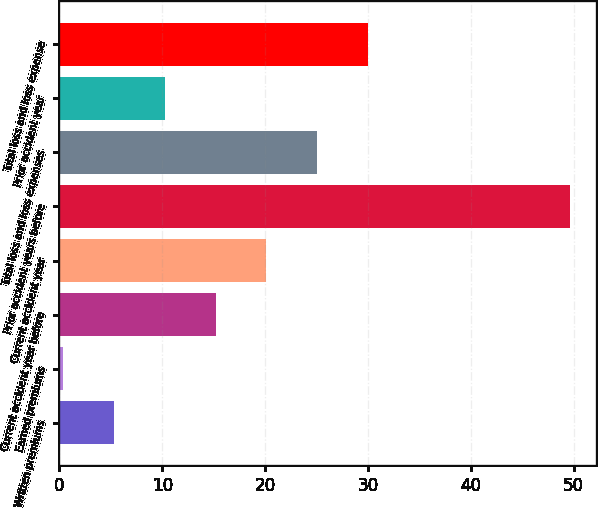Convert chart to OTSL. <chart><loc_0><loc_0><loc_500><loc_500><bar_chart><fcel>Written premiums<fcel>Earned premiums<fcel>Current accident year before<fcel>Current accident year<fcel>Prior accident years before<fcel>Total loss and loss expenses<fcel>Prior accident year<fcel>Total loss and loss expense<nl><fcel>5.33<fcel>0.4<fcel>15.19<fcel>20.12<fcel>49.7<fcel>25.05<fcel>10.26<fcel>29.98<nl></chart> 